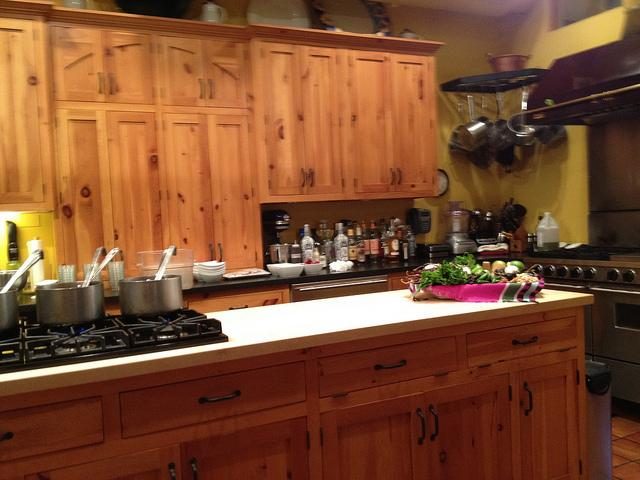What is the object called which is supporting the stove? counter 